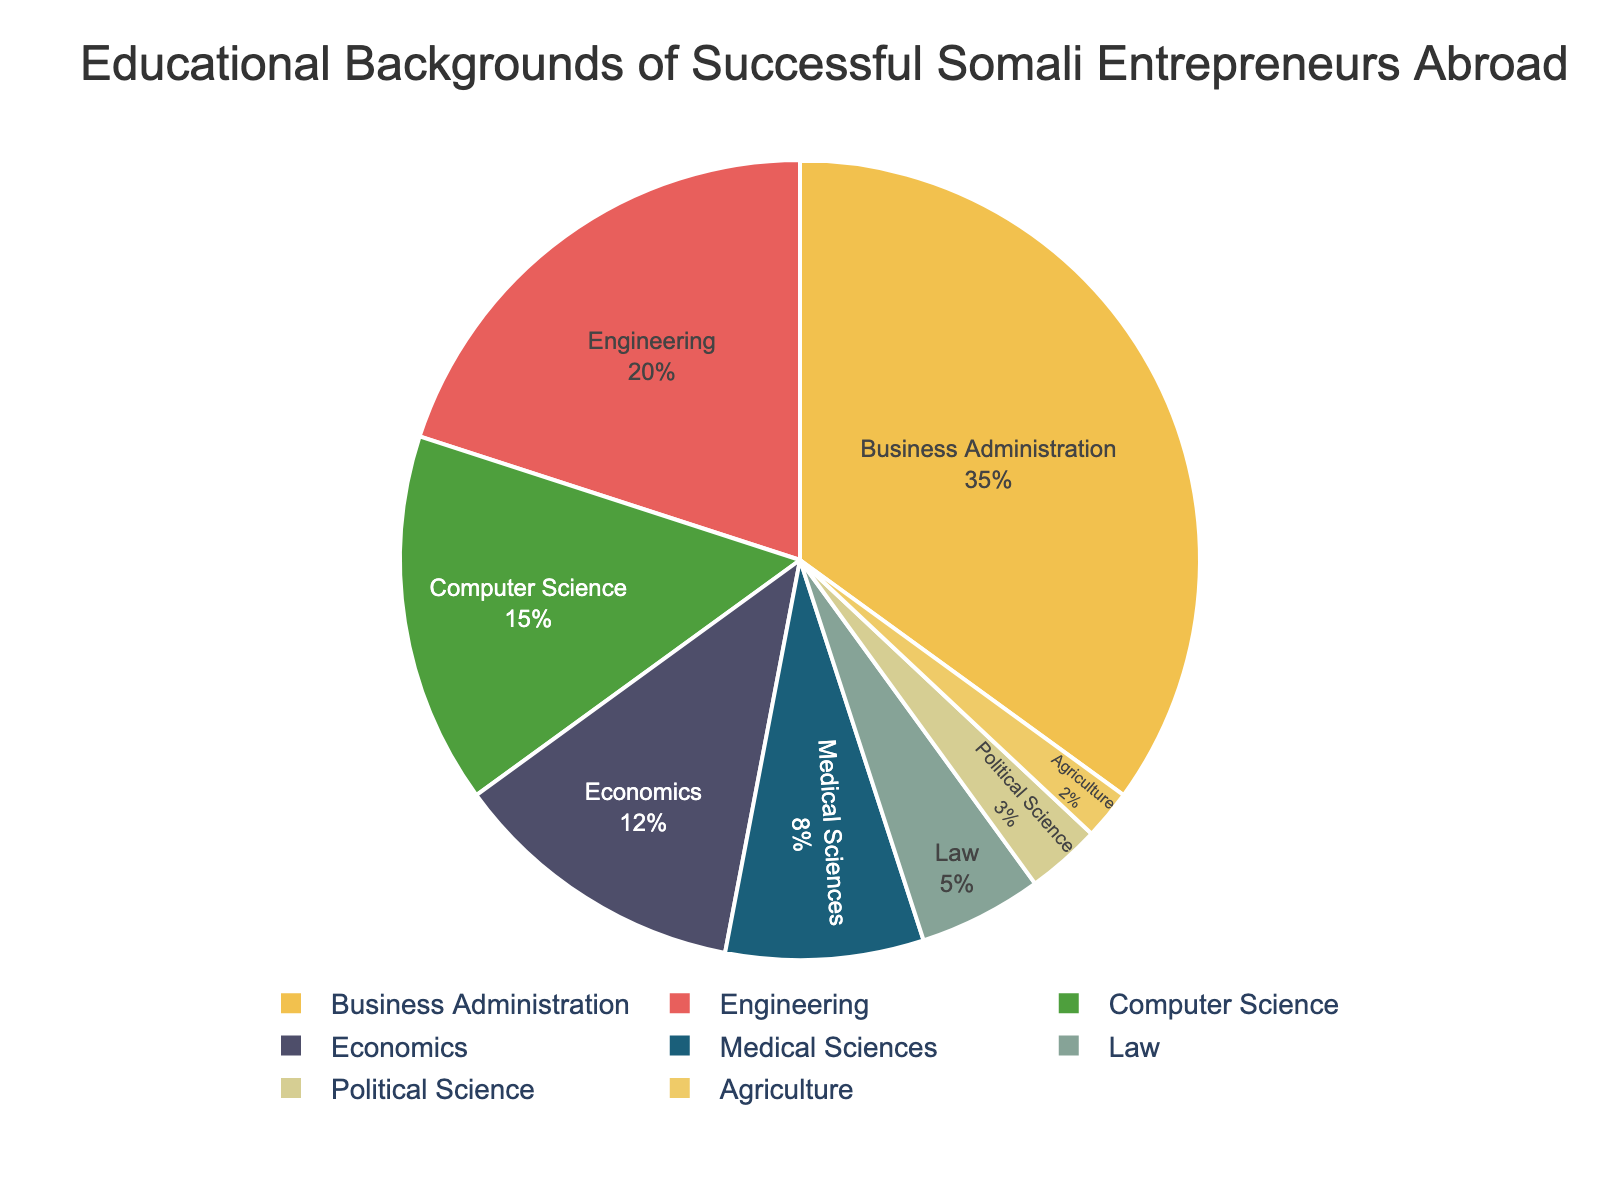What is the most common educational background among successful Somali entrepreneurs in foreign countries? The pie chart shows the distribution of educational backgrounds. The largest slice is for Business Administration, which has the highest percentage.
Answer: Business Administration Which educational background has the smallest representation? The smallest slice in the pie chart represents Agriculture, indicating it has the lowest percentage of educational backgrounds among the entrepreneurs.
Answer: Agriculture What percentage of successful Somali entrepreneurs have a background in Medical Sciences or Law? According to the pie chart, Medical Sciences is 8% and Law is 5%. Summing these together: 8% + 5% = 13%.
Answer: 13% How does the percentage of Business Administration compare to Engineering? According to the pie chart, Business Administration is 35%, and Engineering is 20%. Business Administration has a higher percentage compared to Engineering.
Answer: Business Administration is higher If you combine the percentage of those from Computer Science and Economics backgrounds, how much of the total does this combination represent? The chart shows Computer Science at 15% and Economics at 12%. Adding these gives: 15% + 12% = 27%.
Answer: 27% What visual attribute distinguishes the different educational backgrounds in the pie chart? The pie chart uses different colors for each educational background to distinguish them visually.
Answer: Different colors How much higher is the percentage of entrepreneurs with a background in Business Administration compared to those with a Medical Sciences background? The chart shows Business Administration at 35% and Medical Sciences at 8%. The difference is: 35% - 8% = 27%.
Answer: 27% Which two educational backgrounds combined make up the smallest percentage of the pie chart? The chart shows that Political Science is 3% and Agriculture is 2%. Combined, they make up: 3% + 2% = 5%, which is the smallest among possible combinations of two categories.
Answer: Political Science and Agriculture 